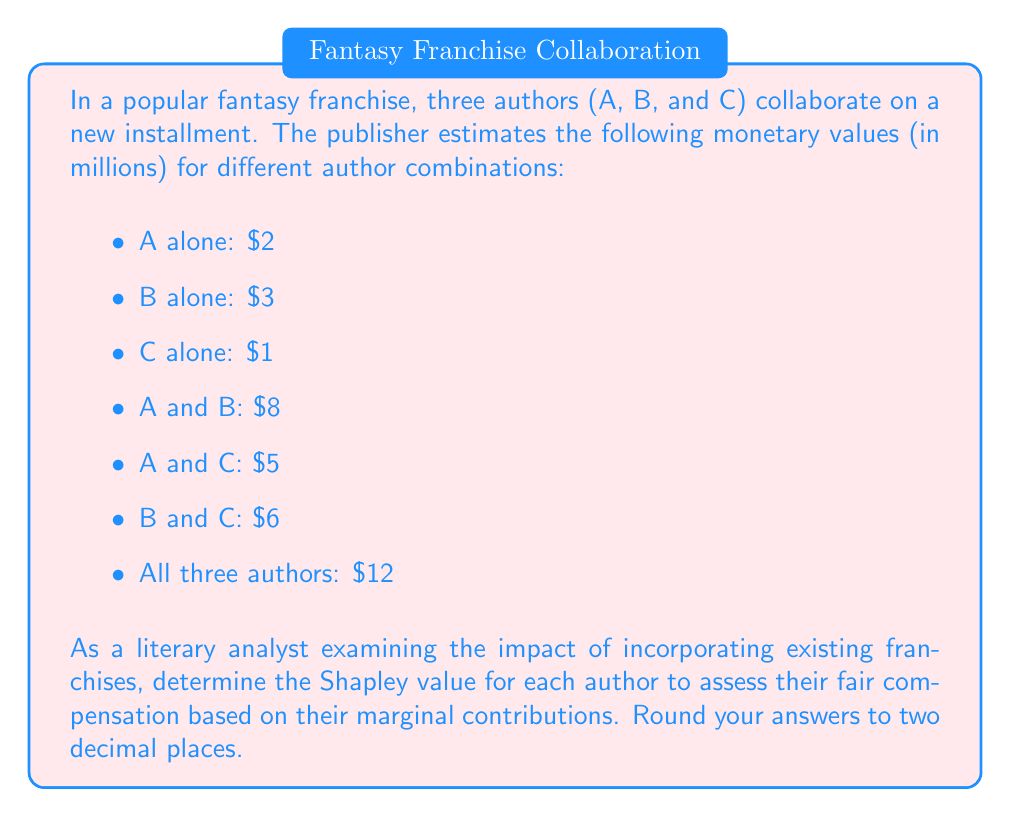Show me your answer to this math problem. To calculate the Shapley value for each author, we need to consider all possible orderings of the authors and their marginal contributions. There are 3! = 6 possible orderings.

Let's calculate the marginal contribution for each author in each ordering:

1. ABC: A = 2, B = 6, C = 4
2. ACB: A = 2, C = 3, B = 7
3. BAC: B = 3, A = 5, C = 4
4. BCA: B = 3, C = 3, A = 6
5. CAB: C = 1, A = 4, B = 7
6. CBA: C = 1, B = 5, A = 6

Now, we calculate the average contribution for each author:

Author A:
$$ \text{Shapley Value}_A = \frac{2 + 2 + 5 + 6 + 4 + 6}{6} = \frac{25}{6} \approx 4.17 $$

Author B:
$$ \text{Shapley Value}_B = \frac{6 + 7 + 3 + 3 + 7 + 5}{6} = \frac{31}{6} \approx 5.17 $$

Author C:
$$ \text{Shapley Value}_C = \frac{4 + 3 + 4 + 3 + 1 + 1}{6} = \frac{16}{6} \approx 2.67 $$

The Shapley values represent the fair compensation for each author based on their marginal contributions to the collaborative work, taking into account the value of the existing franchise and each author's individual impact.
Answer: Author A: $4.17 million
Author B: $5.17 million
Author C: $2.67 million 